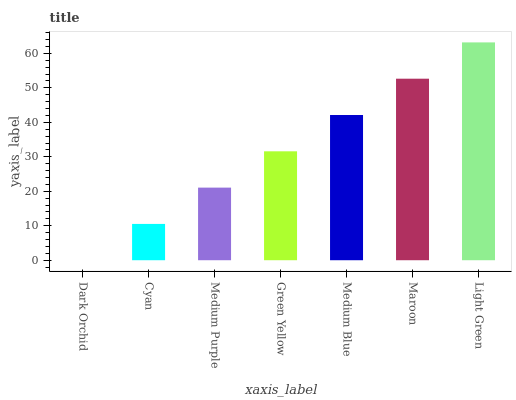Is Dark Orchid the minimum?
Answer yes or no. Yes. Is Light Green the maximum?
Answer yes or no. Yes. Is Cyan the minimum?
Answer yes or no. No. Is Cyan the maximum?
Answer yes or no. No. Is Cyan greater than Dark Orchid?
Answer yes or no. Yes. Is Dark Orchid less than Cyan?
Answer yes or no. Yes. Is Dark Orchid greater than Cyan?
Answer yes or no. No. Is Cyan less than Dark Orchid?
Answer yes or no. No. Is Green Yellow the high median?
Answer yes or no. Yes. Is Green Yellow the low median?
Answer yes or no. Yes. Is Dark Orchid the high median?
Answer yes or no. No. Is Maroon the low median?
Answer yes or no. No. 